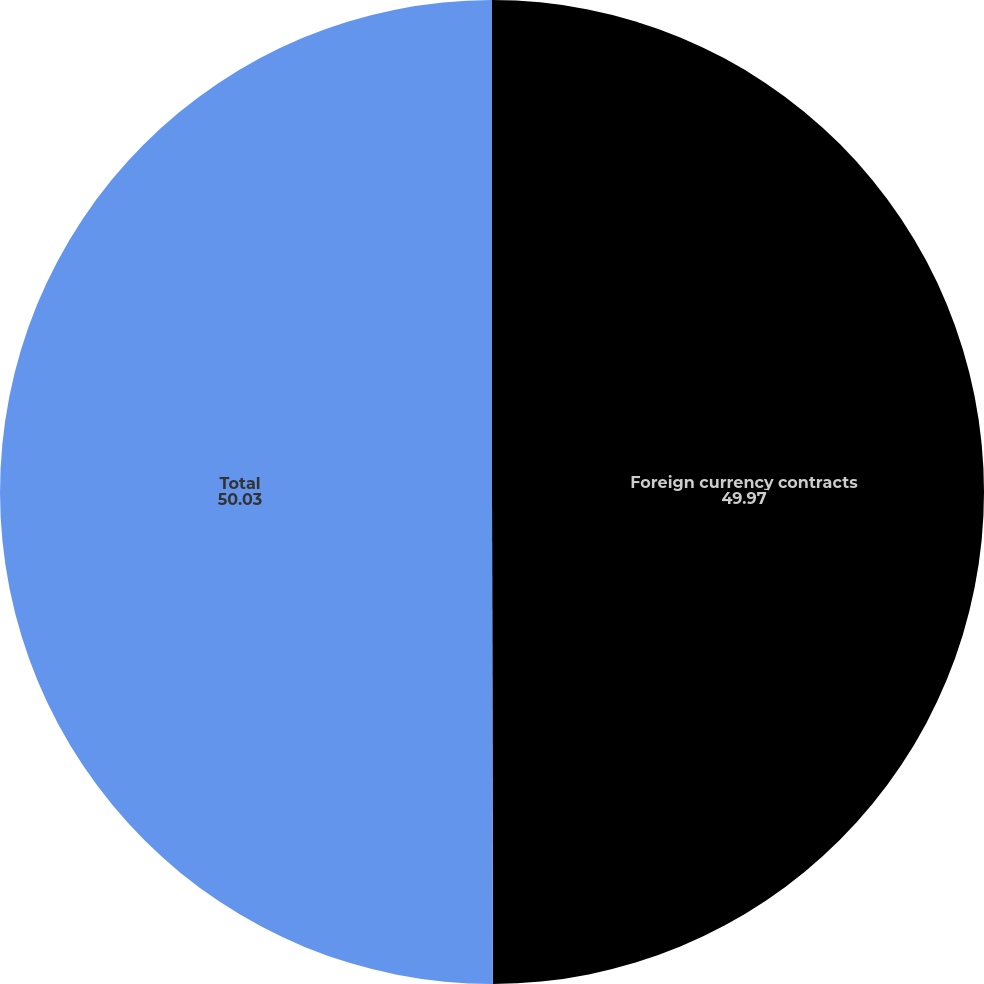<chart> <loc_0><loc_0><loc_500><loc_500><pie_chart><fcel>Foreign currency contracts<fcel>Total<nl><fcel>49.97%<fcel>50.03%<nl></chart> 